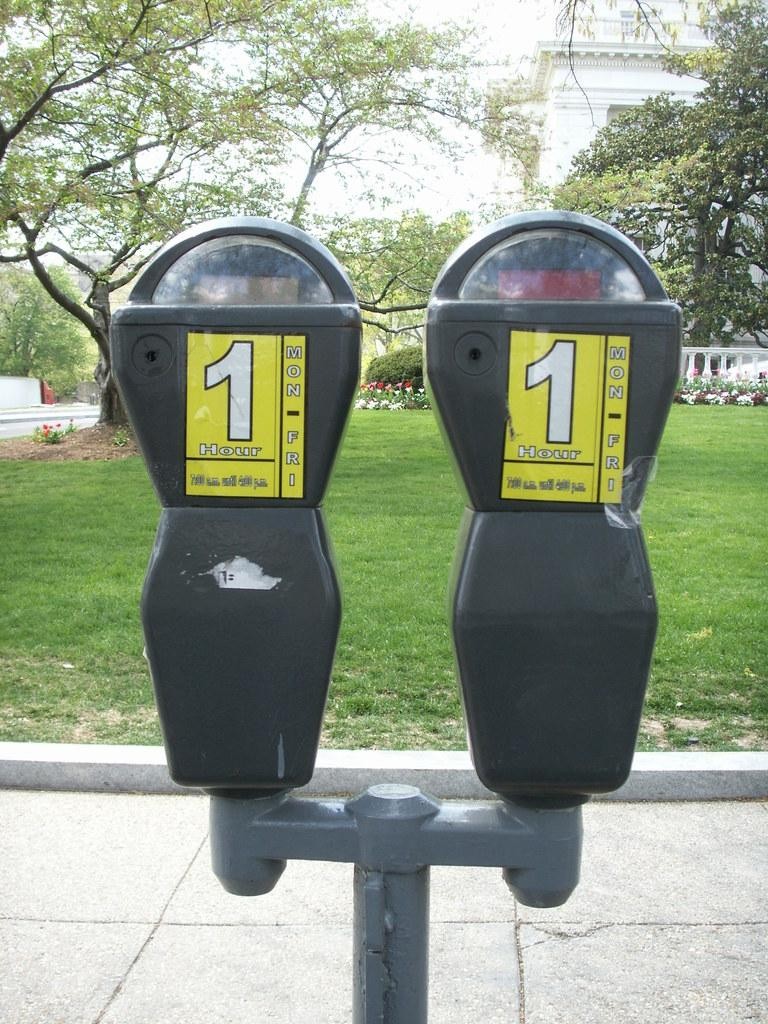<image>
Render a clear and concise summary of the photo. Two parking meters that say 1 hour on them. 